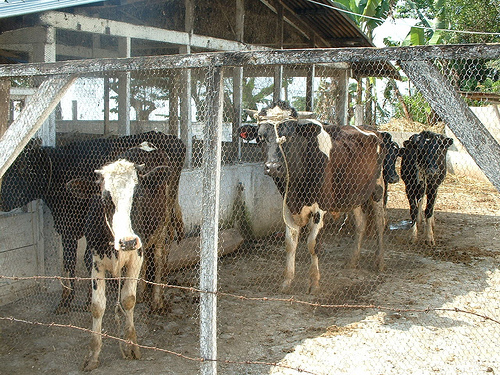What can you tell about the environment the cows are in? The cows are situated in a rudimentary fenced enclosure, possibly a small-scale farm or holding area. The fence is made of wire mesh supported by wooden poles. There's a simple open-air shelter with a tin roof providing some shade. With trees and open sky visible in the background, this setting suggests a rural countryside location, where the cows have basic shelter but likely also have access to outdoor grazing areas. 